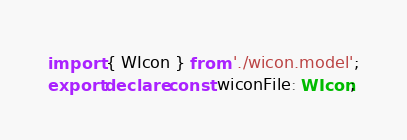<code> <loc_0><loc_0><loc_500><loc_500><_TypeScript_>import { WIcon } from './wicon.model';
export declare const wiconFile: WIcon;
</code> 